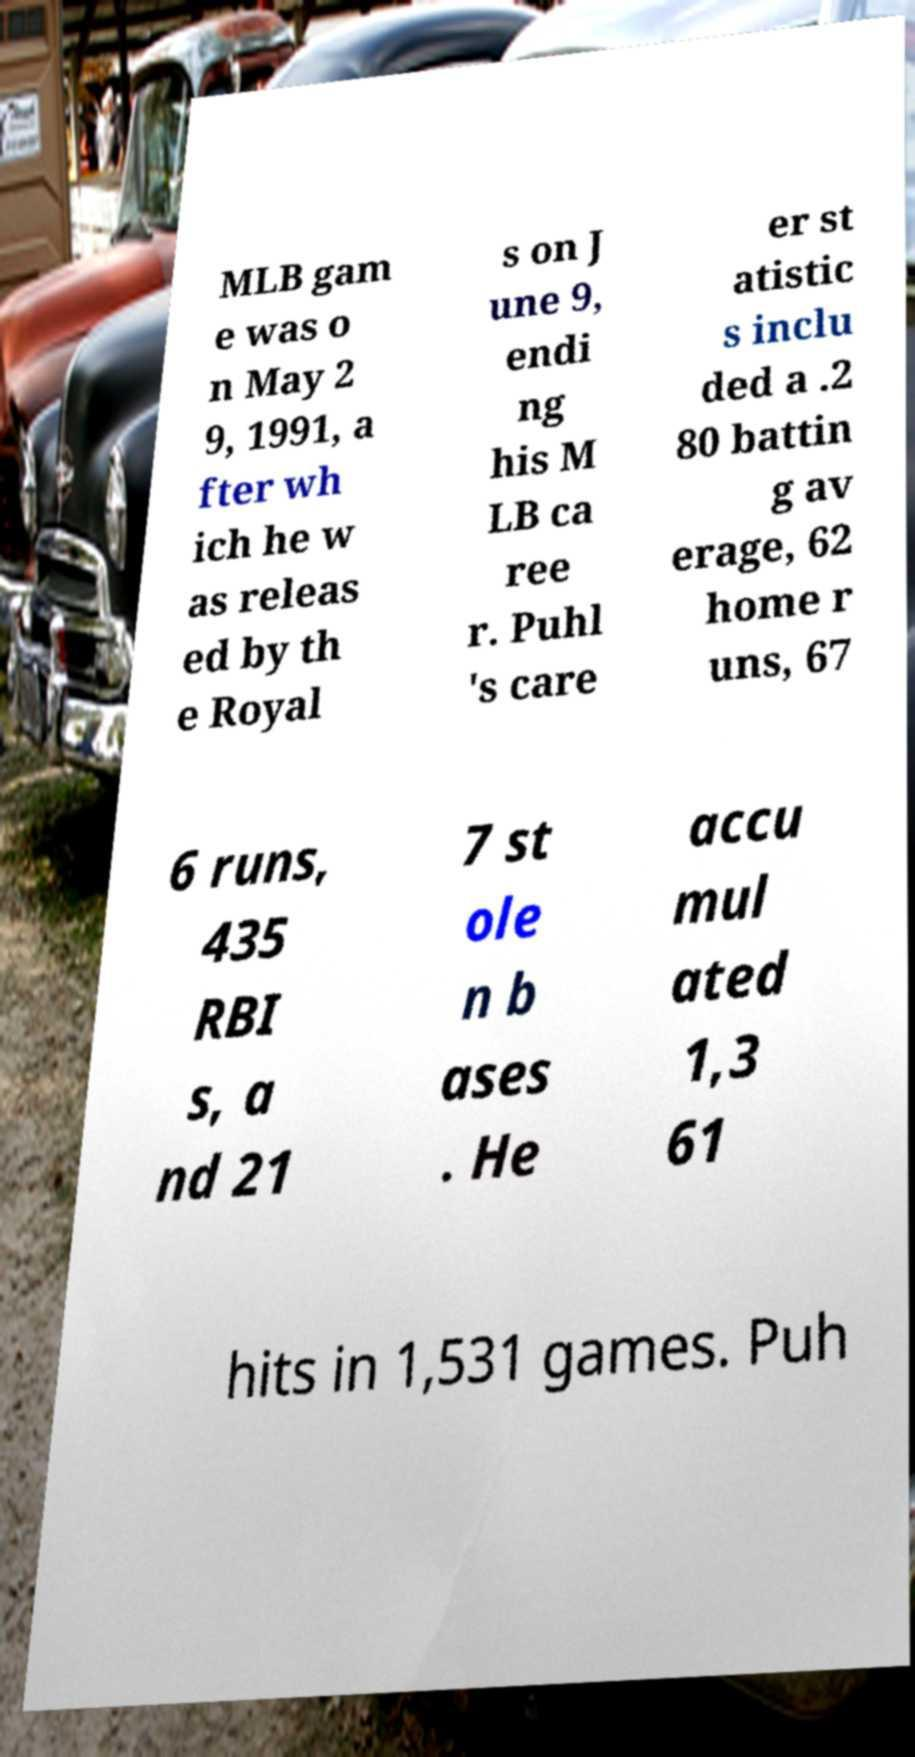There's text embedded in this image that I need extracted. Can you transcribe it verbatim? MLB gam e was o n May 2 9, 1991, a fter wh ich he w as releas ed by th e Royal s on J une 9, endi ng his M LB ca ree r. Puhl 's care er st atistic s inclu ded a .2 80 battin g av erage, 62 home r uns, 67 6 runs, 435 RBI s, a nd 21 7 st ole n b ases . He accu mul ated 1,3 61 hits in 1,531 games. Puh 